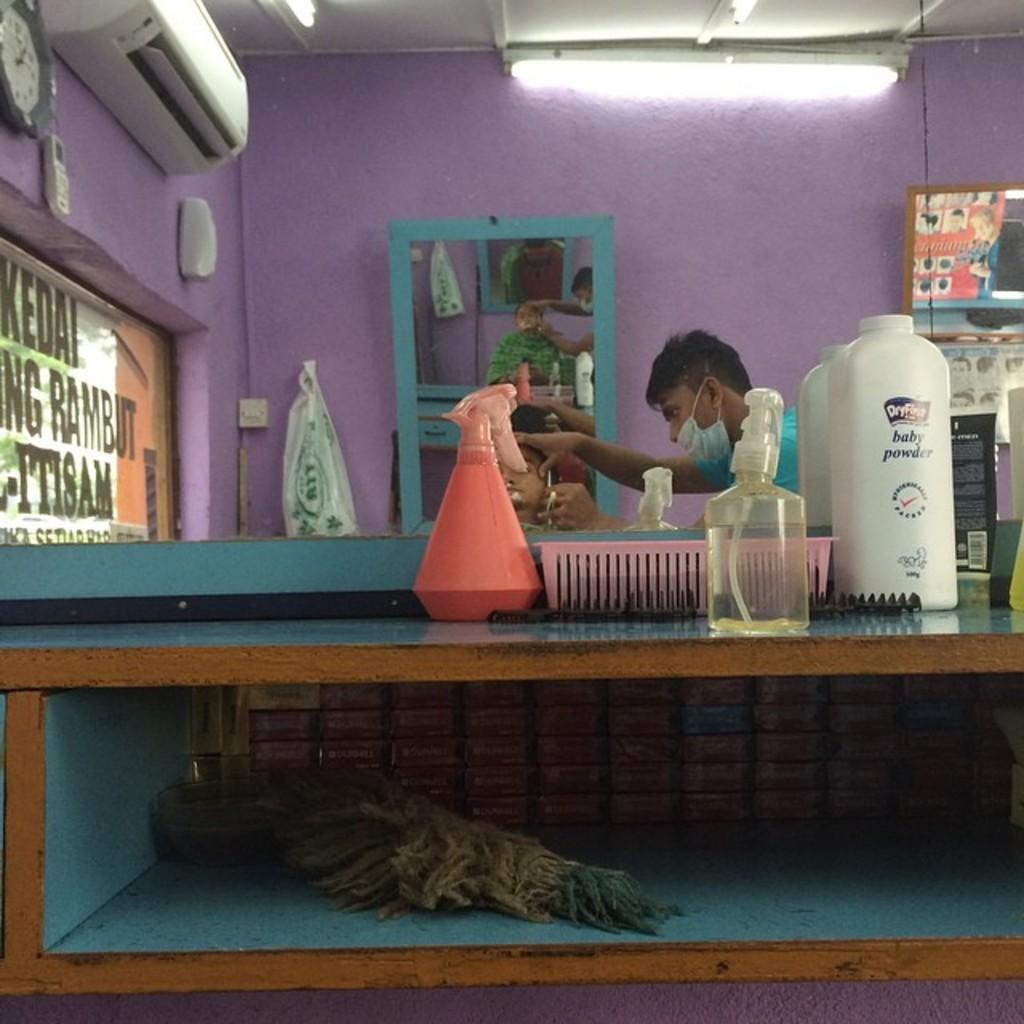<image>
Relay a brief, clear account of the picture shown. A big white bottle of baby powder sitting on a table. 